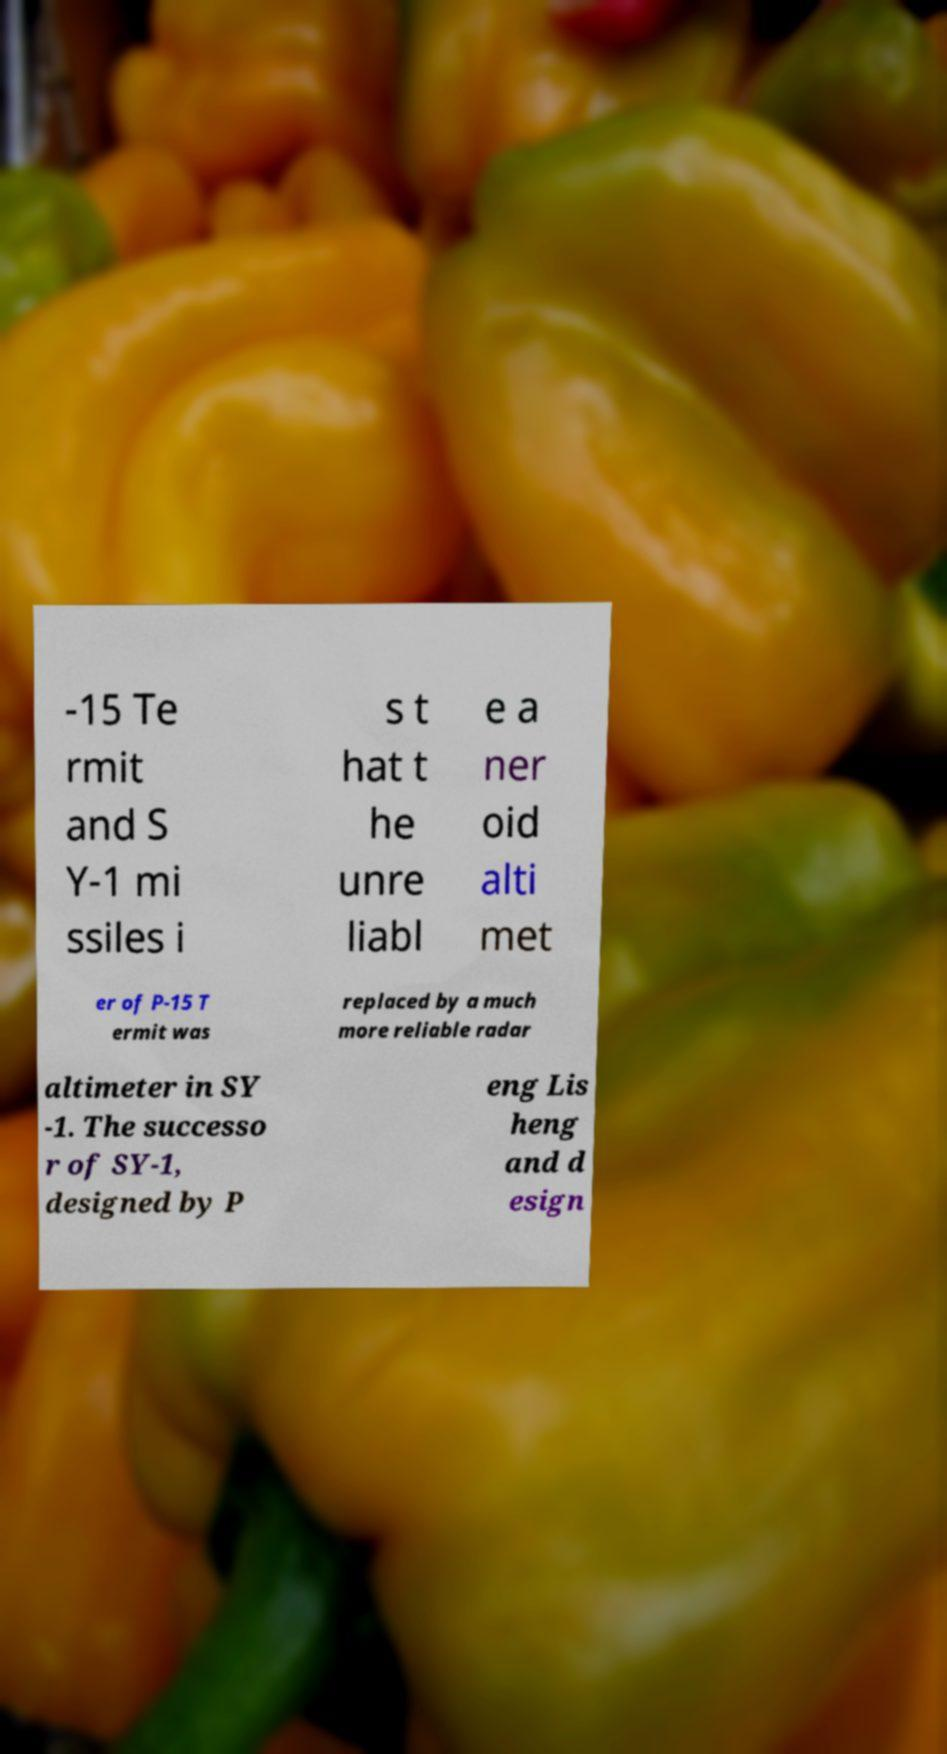Please read and relay the text visible in this image. What does it say? -15 Te rmit and S Y-1 mi ssiles i s t hat t he unre liabl e a ner oid alti met er of P-15 T ermit was replaced by a much more reliable radar altimeter in SY -1. The successo r of SY-1, designed by P eng Lis heng and d esign 